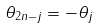Convert formula to latex. <formula><loc_0><loc_0><loc_500><loc_500>\theta _ { 2 n - j } = - \theta _ { j }</formula> 